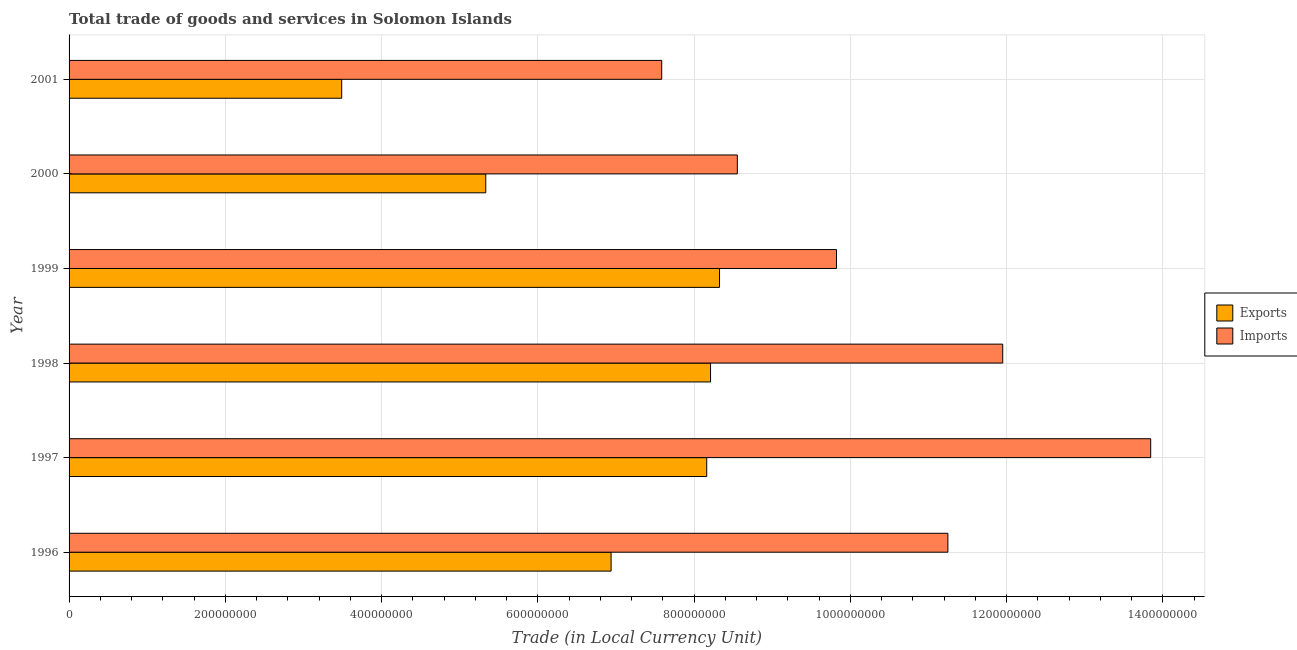Are the number of bars per tick equal to the number of legend labels?
Provide a succinct answer. Yes. How many bars are there on the 3rd tick from the bottom?
Make the answer very short. 2. What is the label of the 1st group of bars from the top?
Ensure brevity in your answer.  2001. What is the imports of goods and services in 1998?
Offer a terse response. 1.20e+09. Across all years, what is the maximum export of goods and services?
Keep it short and to the point. 8.33e+08. Across all years, what is the minimum export of goods and services?
Ensure brevity in your answer.  3.49e+08. In which year was the imports of goods and services maximum?
Your response must be concise. 1997. In which year was the export of goods and services minimum?
Keep it short and to the point. 2001. What is the total imports of goods and services in the graph?
Offer a terse response. 6.30e+09. What is the difference between the export of goods and services in 1997 and that in 2001?
Offer a very short reply. 4.67e+08. What is the difference between the imports of goods and services in 2000 and the export of goods and services in 2001?
Offer a terse response. 5.06e+08. What is the average imports of goods and services per year?
Your answer should be compact. 1.05e+09. In the year 1997, what is the difference between the imports of goods and services and export of goods and services?
Make the answer very short. 5.68e+08. In how many years, is the imports of goods and services greater than 720000000 LCU?
Keep it short and to the point. 6. What is the ratio of the export of goods and services in 1996 to that in 2000?
Offer a terse response. 1.3. Is the export of goods and services in 1999 less than that in 2000?
Provide a short and direct response. No. What is the difference between the highest and the second highest export of goods and services?
Ensure brevity in your answer.  1.15e+07. What is the difference between the highest and the lowest imports of goods and services?
Your answer should be very brief. 6.26e+08. In how many years, is the imports of goods and services greater than the average imports of goods and services taken over all years?
Provide a succinct answer. 3. Is the sum of the export of goods and services in 2000 and 2001 greater than the maximum imports of goods and services across all years?
Ensure brevity in your answer.  No. What does the 2nd bar from the top in 2001 represents?
Your response must be concise. Exports. What does the 1st bar from the bottom in 1998 represents?
Offer a terse response. Exports. How many bars are there?
Provide a succinct answer. 12. Are all the bars in the graph horizontal?
Ensure brevity in your answer.  Yes. How many years are there in the graph?
Give a very brief answer. 6. Are the values on the major ticks of X-axis written in scientific E-notation?
Give a very brief answer. No. Does the graph contain any zero values?
Ensure brevity in your answer.  No. Does the graph contain grids?
Provide a short and direct response. Yes. Where does the legend appear in the graph?
Keep it short and to the point. Center right. What is the title of the graph?
Your answer should be very brief. Total trade of goods and services in Solomon Islands. Does "Export" appear as one of the legend labels in the graph?
Your response must be concise. No. What is the label or title of the X-axis?
Offer a very short reply. Trade (in Local Currency Unit). What is the Trade (in Local Currency Unit) of Exports in 1996?
Make the answer very short. 6.94e+08. What is the Trade (in Local Currency Unit) of Imports in 1996?
Offer a terse response. 1.12e+09. What is the Trade (in Local Currency Unit) in Exports in 1997?
Your response must be concise. 8.16e+08. What is the Trade (in Local Currency Unit) in Imports in 1997?
Provide a short and direct response. 1.38e+09. What is the Trade (in Local Currency Unit) in Exports in 1998?
Make the answer very short. 8.21e+08. What is the Trade (in Local Currency Unit) in Imports in 1998?
Make the answer very short. 1.20e+09. What is the Trade (in Local Currency Unit) of Exports in 1999?
Offer a very short reply. 8.33e+08. What is the Trade (in Local Currency Unit) in Imports in 1999?
Your response must be concise. 9.82e+08. What is the Trade (in Local Currency Unit) in Exports in 2000?
Your response must be concise. 5.33e+08. What is the Trade (in Local Currency Unit) in Imports in 2000?
Your response must be concise. 8.55e+08. What is the Trade (in Local Currency Unit) in Exports in 2001?
Your answer should be compact. 3.49e+08. What is the Trade (in Local Currency Unit) in Imports in 2001?
Keep it short and to the point. 7.59e+08. Across all years, what is the maximum Trade (in Local Currency Unit) in Exports?
Offer a terse response. 8.33e+08. Across all years, what is the maximum Trade (in Local Currency Unit) in Imports?
Provide a short and direct response. 1.38e+09. Across all years, what is the minimum Trade (in Local Currency Unit) of Exports?
Your response must be concise. 3.49e+08. Across all years, what is the minimum Trade (in Local Currency Unit) in Imports?
Offer a terse response. 7.59e+08. What is the total Trade (in Local Currency Unit) in Exports in the graph?
Offer a very short reply. 4.05e+09. What is the total Trade (in Local Currency Unit) of Imports in the graph?
Your answer should be very brief. 6.30e+09. What is the difference between the Trade (in Local Currency Unit) in Exports in 1996 and that in 1997?
Your answer should be very brief. -1.22e+08. What is the difference between the Trade (in Local Currency Unit) of Imports in 1996 and that in 1997?
Offer a very short reply. -2.60e+08. What is the difference between the Trade (in Local Currency Unit) in Exports in 1996 and that in 1998?
Your answer should be very brief. -1.27e+08. What is the difference between the Trade (in Local Currency Unit) of Imports in 1996 and that in 1998?
Your response must be concise. -7.02e+07. What is the difference between the Trade (in Local Currency Unit) in Exports in 1996 and that in 1999?
Your response must be concise. -1.39e+08. What is the difference between the Trade (in Local Currency Unit) in Imports in 1996 and that in 1999?
Your response must be concise. 1.43e+08. What is the difference between the Trade (in Local Currency Unit) in Exports in 1996 and that in 2000?
Ensure brevity in your answer.  1.60e+08. What is the difference between the Trade (in Local Currency Unit) in Imports in 1996 and that in 2000?
Your answer should be very brief. 2.70e+08. What is the difference between the Trade (in Local Currency Unit) in Exports in 1996 and that in 2001?
Your answer should be very brief. 3.45e+08. What is the difference between the Trade (in Local Currency Unit) of Imports in 1996 and that in 2001?
Keep it short and to the point. 3.66e+08. What is the difference between the Trade (in Local Currency Unit) in Exports in 1997 and that in 1998?
Your response must be concise. -4.90e+06. What is the difference between the Trade (in Local Currency Unit) of Imports in 1997 and that in 1998?
Offer a very short reply. 1.89e+08. What is the difference between the Trade (in Local Currency Unit) of Exports in 1997 and that in 1999?
Give a very brief answer. -1.64e+07. What is the difference between the Trade (in Local Currency Unit) of Imports in 1997 and that in 1999?
Provide a succinct answer. 4.02e+08. What is the difference between the Trade (in Local Currency Unit) of Exports in 1997 and that in 2000?
Offer a terse response. 2.83e+08. What is the difference between the Trade (in Local Currency Unit) of Imports in 1997 and that in 2000?
Offer a terse response. 5.29e+08. What is the difference between the Trade (in Local Currency Unit) in Exports in 1997 and that in 2001?
Ensure brevity in your answer.  4.67e+08. What is the difference between the Trade (in Local Currency Unit) in Imports in 1997 and that in 2001?
Keep it short and to the point. 6.26e+08. What is the difference between the Trade (in Local Currency Unit) in Exports in 1998 and that in 1999?
Offer a very short reply. -1.15e+07. What is the difference between the Trade (in Local Currency Unit) of Imports in 1998 and that in 1999?
Make the answer very short. 2.13e+08. What is the difference between the Trade (in Local Currency Unit) in Exports in 1998 and that in 2000?
Give a very brief answer. 2.88e+08. What is the difference between the Trade (in Local Currency Unit) of Imports in 1998 and that in 2000?
Make the answer very short. 3.40e+08. What is the difference between the Trade (in Local Currency Unit) in Exports in 1998 and that in 2001?
Offer a terse response. 4.72e+08. What is the difference between the Trade (in Local Currency Unit) of Imports in 1998 and that in 2001?
Your answer should be compact. 4.36e+08. What is the difference between the Trade (in Local Currency Unit) of Exports in 1999 and that in 2000?
Keep it short and to the point. 2.99e+08. What is the difference between the Trade (in Local Currency Unit) of Imports in 1999 and that in 2000?
Make the answer very short. 1.27e+08. What is the difference between the Trade (in Local Currency Unit) in Exports in 1999 and that in 2001?
Your response must be concise. 4.84e+08. What is the difference between the Trade (in Local Currency Unit) of Imports in 1999 and that in 2001?
Keep it short and to the point. 2.24e+08. What is the difference between the Trade (in Local Currency Unit) of Exports in 2000 and that in 2001?
Ensure brevity in your answer.  1.84e+08. What is the difference between the Trade (in Local Currency Unit) in Imports in 2000 and that in 2001?
Provide a short and direct response. 9.68e+07. What is the difference between the Trade (in Local Currency Unit) in Exports in 1996 and the Trade (in Local Currency Unit) in Imports in 1997?
Give a very brief answer. -6.91e+08. What is the difference between the Trade (in Local Currency Unit) of Exports in 1996 and the Trade (in Local Currency Unit) of Imports in 1998?
Make the answer very short. -5.01e+08. What is the difference between the Trade (in Local Currency Unit) of Exports in 1996 and the Trade (in Local Currency Unit) of Imports in 1999?
Offer a terse response. -2.88e+08. What is the difference between the Trade (in Local Currency Unit) in Exports in 1996 and the Trade (in Local Currency Unit) in Imports in 2000?
Make the answer very short. -1.62e+08. What is the difference between the Trade (in Local Currency Unit) in Exports in 1996 and the Trade (in Local Currency Unit) in Imports in 2001?
Offer a very short reply. -6.48e+07. What is the difference between the Trade (in Local Currency Unit) of Exports in 1997 and the Trade (in Local Currency Unit) of Imports in 1998?
Your answer should be very brief. -3.79e+08. What is the difference between the Trade (in Local Currency Unit) of Exports in 1997 and the Trade (in Local Currency Unit) of Imports in 1999?
Give a very brief answer. -1.66e+08. What is the difference between the Trade (in Local Currency Unit) of Exports in 1997 and the Trade (in Local Currency Unit) of Imports in 2000?
Provide a succinct answer. -3.92e+07. What is the difference between the Trade (in Local Currency Unit) in Exports in 1997 and the Trade (in Local Currency Unit) in Imports in 2001?
Your answer should be compact. 5.76e+07. What is the difference between the Trade (in Local Currency Unit) in Exports in 1998 and the Trade (in Local Currency Unit) in Imports in 1999?
Provide a short and direct response. -1.61e+08. What is the difference between the Trade (in Local Currency Unit) in Exports in 1998 and the Trade (in Local Currency Unit) in Imports in 2000?
Your response must be concise. -3.43e+07. What is the difference between the Trade (in Local Currency Unit) in Exports in 1998 and the Trade (in Local Currency Unit) in Imports in 2001?
Give a very brief answer. 6.25e+07. What is the difference between the Trade (in Local Currency Unit) of Exports in 1999 and the Trade (in Local Currency Unit) of Imports in 2000?
Make the answer very short. -2.28e+07. What is the difference between the Trade (in Local Currency Unit) in Exports in 1999 and the Trade (in Local Currency Unit) in Imports in 2001?
Provide a short and direct response. 7.40e+07. What is the difference between the Trade (in Local Currency Unit) in Exports in 2000 and the Trade (in Local Currency Unit) in Imports in 2001?
Provide a succinct answer. -2.25e+08. What is the average Trade (in Local Currency Unit) of Exports per year?
Give a very brief answer. 6.74e+08. What is the average Trade (in Local Currency Unit) in Imports per year?
Offer a very short reply. 1.05e+09. In the year 1996, what is the difference between the Trade (in Local Currency Unit) of Exports and Trade (in Local Currency Unit) of Imports?
Offer a terse response. -4.31e+08. In the year 1997, what is the difference between the Trade (in Local Currency Unit) in Exports and Trade (in Local Currency Unit) in Imports?
Offer a very short reply. -5.68e+08. In the year 1998, what is the difference between the Trade (in Local Currency Unit) of Exports and Trade (in Local Currency Unit) of Imports?
Ensure brevity in your answer.  -3.74e+08. In the year 1999, what is the difference between the Trade (in Local Currency Unit) of Exports and Trade (in Local Currency Unit) of Imports?
Give a very brief answer. -1.50e+08. In the year 2000, what is the difference between the Trade (in Local Currency Unit) in Exports and Trade (in Local Currency Unit) in Imports?
Make the answer very short. -3.22e+08. In the year 2001, what is the difference between the Trade (in Local Currency Unit) of Exports and Trade (in Local Currency Unit) of Imports?
Provide a short and direct response. -4.10e+08. What is the ratio of the Trade (in Local Currency Unit) of Imports in 1996 to that in 1997?
Ensure brevity in your answer.  0.81. What is the ratio of the Trade (in Local Currency Unit) of Exports in 1996 to that in 1998?
Offer a very short reply. 0.84. What is the ratio of the Trade (in Local Currency Unit) of Imports in 1996 to that in 1998?
Your response must be concise. 0.94. What is the ratio of the Trade (in Local Currency Unit) of Exports in 1996 to that in 1999?
Make the answer very short. 0.83. What is the ratio of the Trade (in Local Currency Unit) of Imports in 1996 to that in 1999?
Ensure brevity in your answer.  1.15. What is the ratio of the Trade (in Local Currency Unit) in Exports in 1996 to that in 2000?
Give a very brief answer. 1.3. What is the ratio of the Trade (in Local Currency Unit) in Imports in 1996 to that in 2000?
Your answer should be compact. 1.32. What is the ratio of the Trade (in Local Currency Unit) of Exports in 1996 to that in 2001?
Give a very brief answer. 1.99. What is the ratio of the Trade (in Local Currency Unit) in Imports in 1996 to that in 2001?
Ensure brevity in your answer.  1.48. What is the ratio of the Trade (in Local Currency Unit) in Imports in 1997 to that in 1998?
Your answer should be very brief. 1.16. What is the ratio of the Trade (in Local Currency Unit) in Exports in 1997 to that in 1999?
Provide a succinct answer. 0.98. What is the ratio of the Trade (in Local Currency Unit) of Imports in 1997 to that in 1999?
Your answer should be compact. 1.41. What is the ratio of the Trade (in Local Currency Unit) in Exports in 1997 to that in 2000?
Your response must be concise. 1.53. What is the ratio of the Trade (in Local Currency Unit) of Imports in 1997 to that in 2000?
Give a very brief answer. 1.62. What is the ratio of the Trade (in Local Currency Unit) in Exports in 1997 to that in 2001?
Make the answer very short. 2.34. What is the ratio of the Trade (in Local Currency Unit) of Imports in 1997 to that in 2001?
Offer a terse response. 1.83. What is the ratio of the Trade (in Local Currency Unit) of Exports in 1998 to that in 1999?
Your response must be concise. 0.99. What is the ratio of the Trade (in Local Currency Unit) of Imports in 1998 to that in 1999?
Ensure brevity in your answer.  1.22. What is the ratio of the Trade (in Local Currency Unit) of Exports in 1998 to that in 2000?
Give a very brief answer. 1.54. What is the ratio of the Trade (in Local Currency Unit) in Imports in 1998 to that in 2000?
Your response must be concise. 1.4. What is the ratio of the Trade (in Local Currency Unit) of Exports in 1998 to that in 2001?
Your answer should be very brief. 2.35. What is the ratio of the Trade (in Local Currency Unit) in Imports in 1998 to that in 2001?
Provide a succinct answer. 1.58. What is the ratio of the Trade (in Local Currency Unit) in Exports in 1999 to that in 2000?
Your response must be concise. 1.56. What is the ratio of the Trade (in Local Currency Unit) of Imports in 1999 to that in 2000?
Make the answer very short. 1.15. What is the ratio of the Trade (in Local Currency Unit) of Exports in 1999 to that in 2001?
Your response must be concise. 2.39. What is the ratio of the Trade (in Local Currency Unit) in Imports in 1999 to that in 2001?
Provide a short and direct response. 1.29. What is the ratio of the Trade (in Local Currency Unit) of Exports in 2000 to that in 2001?
Your response must be concise. 1.53. What is the ratio of the Trade (in Local Currency Unit) in Imports in 2000 to that in 2001?
Make the answer very short. 1.13. What is the difference between the highest and the second highest Trade (in Local Currency Unit) in Exports?
Your answer should be very brief. 1.15e+07. What is the difference between the highest and the second highest Trade (in Local Currency Unit) in Imports?
Make the answer very short. 1.89e+08. What is the difference between the highest and the lowest Trade (in Local Currency Unit) in Exports?
Your answer should be compact. 4.84e+08. What is the difference between the highest and the lowest Trade (in Local Currency Unit) of Imports?
Give a very brief answer. 6.26e+08. 